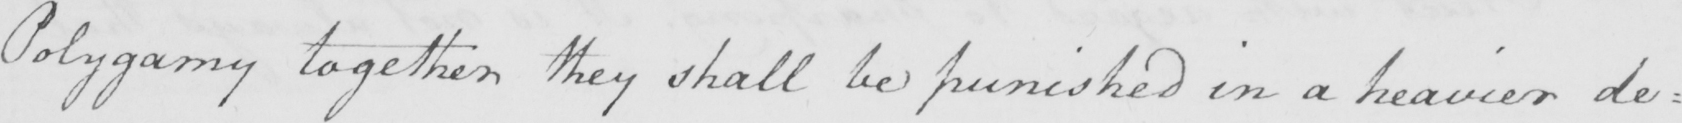Transcribe the text shown in this historical manuscript line. Polygamy together they shall be punished in a heavier degree 